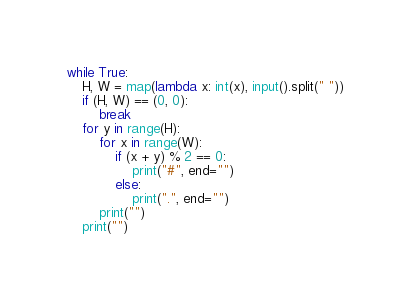Convert code to text. <code><loc_0><loc_0><loc_500><loc_500><_Python_>while True:
    H, W = map(lambda x: int(x), input().split(" "))
    if (H, W) == (0, 0):
        break
    for y in range(H):
        for x in range(W):
            if (x + y) % 2 == 0:
                print("#", end="")
            else:
                print(".", end="")
        print("")
    print("")

</code> 